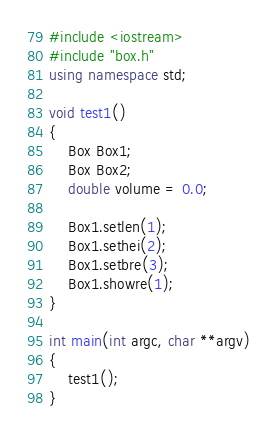Convert code to text. <code><loc_0><loc_0><loc_500><loc_500><_C++_>#include <iostream>
#include "box.h"
using namespace std;

void test1()
{
    Box Box1;
    Box Box2;
    double volume = 0.0;

    Box1.setlen(1);
    Box1.sethei(2);
    Box1.setbre(3);
    Box1.showre(1);
}

int main(int argc, char **argv)
{
    test1();
}
</code> 